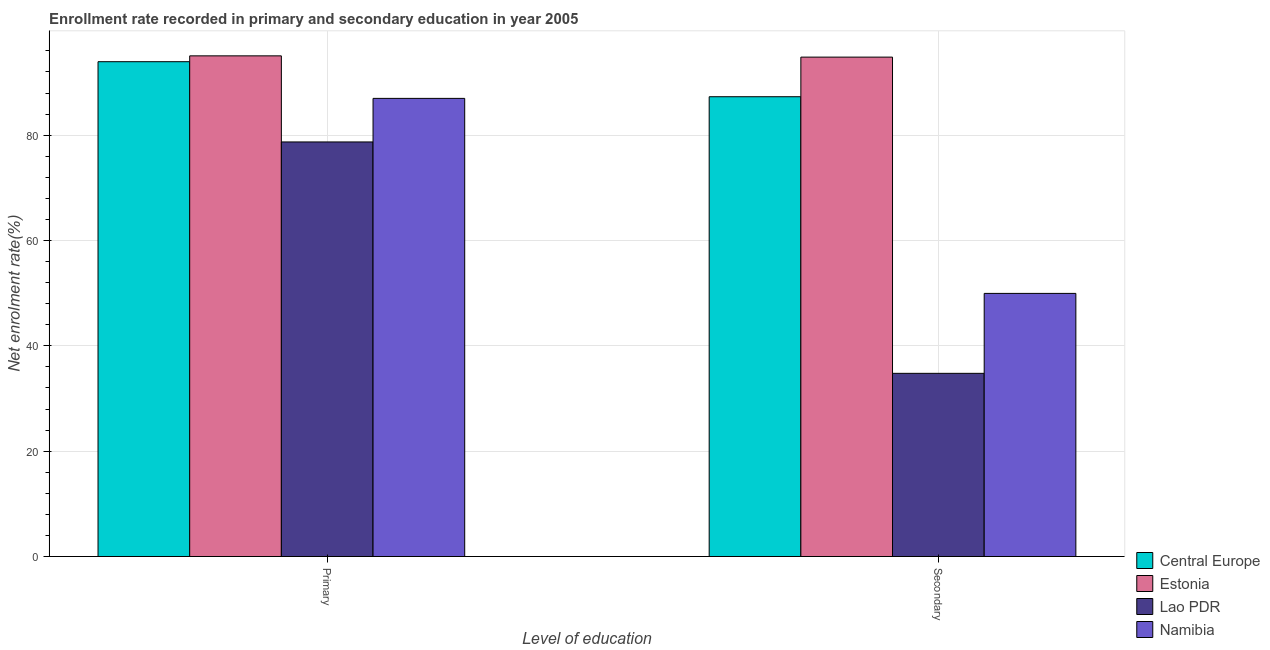How many different coloured bars are there?
Provide a succinct answer. 4. Are the number of bars on each tick of the X-axis equal?
Provide a short and direct response. Yes. How many bars are there on the 1st tick from the left?
Keep it short and to the point. 4. How many bars are there on the 2nd tick from the right?
Keep it short and to the point. 4. What is the label of the 2nd group of bars from the left?
Offer a very short reply. Secondary. What is the enrollment rate in secondary education in Lao PDR?
Offer a terse response. 34.78. Across all countries, what is the maximum enrollment rate in primary education?
Offer a very short reply. 95.05. Across all countries, what is the minimum enrollment rate in secondary education?
Provide a short and direct response. 34.78. In which country was the enrollment rate in secondary education maximum?
Offer a terse response. Estonia. In which country was the enrollment rate in secondary education minimum?
Provide a succinct answer. Lao PDR. What is the total enrollment rate in primary education in the graph?
Offer a terse response. 354.68. What is the difference between the enrollment rate in secondary education in Namibia and that in Central Europe?
Offer a terse response. -37.34. What is the difference between the enrollment rate in secondary education in Lao PDR and the enrollment rate in primary education in Namibia?
Keep it short and to the point. -52.2. What is the average enrollment rate in secondary education per country?
Keep it short and to the point. 66.71. What is the difference between the enrollment rate in secondary education and enrollment rate in primary education in Estonia?
Your answer should be compact. -0.24. In how many countries, is the enrollment rate in secondary education greater than 64 %?
Give a very brief answer. 2. What is the ratio of the enrollment rate in secondary education in Namibia to that in Estonia?
Give a very brief answer. 0.53. What does the 4th bar from the left in Primary represents?
Your answer should be very brief. Namibia. What does the 4th bar from the right in Primary represents?
Your answer should be very brief. Central Europe. How many bars are there?
Make the answer very short. 8. Are all the bars in the graph horizontal?
Offer a terse response. No. How many countries are there in the graph?
Offer a terse response. 4. Are the values on the major ticks of Y-axis written in scientific E-notation?
Ensure brevity in your answer.  No. Does the graph contain any zero values?
Offer a very short reply. No. Does the graph contain grids?
Make the answer very short. Yes. How are the legend labels stacked?
Keep it short and to the point. Vertical. What is the title of the graph?
Your response must be concise. Enrollment rate recorded in primary and secondary education in year 2005. Does "Sao Tome and Principe" appear as one of the legend labels in the graph?
Make the answer very short. No. What is the label or title of the X-axis?
Provide a succinct answer. Level of education. What is the label or title of the Y-axis?
Keep it short and to the point. Net enrolment rate(%). What is the Net enrolment rate(%) in Central Europe in Primary?
Keep it short and to the point. 93.94. What is the Net enrolment rate(%) in Estonia in Primary?
Offer a very short reply. 95.05. What is the Net enrolment rate(%) in Lao PDR in Primary?
Make the answer very short. 78.71. What is the Net enrolment rate(%) of Namibia in Primary?
Give a very brief answer. 86.98. What is the Net enrolment rate(%) in Central Europe in Secondary?
Your answer should be compact. 87.29. What is the Net enrolment rate(%) in Estonia in Secondary?
Your answer should be very brief. 94.81. What is the Net enrolment rate(%) in Lao PDR in Secondary?
Offer a terse response. 34.78. What is the Net enrolment rate(%) of Namibia in Secondary?
Your answer should be very brief. 49.96. Across all Level of education, what is the maximum Net enrolment rate(%) in Central Europe?
Offer a terse response. 93.94. Across all Level of education, what is the maximum Net enrolment rate(%) in Estonia?
Make the answer very short. 95.05. Across all Level of education, what is the maximum Net enrolment rate(%) in Lao PDR?
Ensure brevity in your answer.  78.71. Across all Level of education, what is the maximum Net enrolment rate(%) of Namibia?
Provide a short and direct response. 86.98. Across all Level of education, what is the minimum Net enrolment rate(%) of Central Europe?
Provide a succinct answer. 87.29. Across all Level of education, what is the minimum Net enrolment rate(%) of Estonia?
Ensure brevity in your answer.  94.81. Across all Level of education, what is the minimum Net enrolment rate(%) in Lao PDR?
Provide a succinct answer. 34.78. Across all Level of education, what is the minimum Net enrolment rate(%) in Namibia?
Offer a very short reply. 49.96. What is the total Net enrolment rate(%) of Central Europe in the graph?
Offer a very short reply. 181.24. What is the total Net enrolment rate(%) in Estonia in the graph?
Keep it short and to the point. 189.87. What is the total Net enrolment rate(%) in Lao PDR in the graph?
Your answer should be compact. 113.49. What is the total Net enrolment rate(%) of Namibia in the graph?
Keep it short and to the point. 136.93. What is the difference between the Net enrolment rate(%) of Central Europe in Primary and that in Secondary?
Your answer should be compact. 6.65. What is the difference between the Net enrolment rate(%) of Estonia in Primary and that in Secondary?
Your answer should be compact. 0.24. What is the difference between the Net enrolment rate(%) in Lao PDR in Primary and that in Secondary?
Your response must be concise. 43.93. What is the difference between the Net enrolment rate(%) in Namibia in Primary and that in Secondary?
Your answer should be compact. 37.02. What is the difference between the Net enrolment rate(%) in Central Europe in Primary and the Net enrolment rate(%) in Estonia in Secondary?
Your answer should be very brief. -0.87. What is the difference between the Net enrolment rate(%) in Central Europe in Primary and the Net enrolment rate(%) in Lao PDR in Secondary?
Your response must be concise. 59.16. What is the difference between the Net enrolment rate(%) of Central Europe in Primary and the Net enrolment rate(%) of Namibia in Secondary?
Offer a terse response. 43.99. What is the difference between the Net enrolment rate(%) in Estonia in Primary and the Net enrolment rate(%) in Lao PDR in Secondary?
Keep it short and to the point. 60.27. What is the difference between the Net enrolment rate(%) of Estonia in Primary and the Net enrolment rate(%) of Namibia in Secondary?
Offer a very short reply. 45.1. What is the difference between the Net enrolment rate(%) in Lao PDR in Primary and the Net enrolment rate(%) in Namibia in Secondary?
Your response must be concise. 28.75. What is the average Net enrolment rate(%) of Central Europe per Level of education?
Provide a short and direct response. 90.62. What is the average Net enrolment rate(%) in Estonia per Level of education?
Your response must be concise. 94.93. What is the average Net enrolment rate(%) in Lao PDR per Level of education?
Your answer should be very brief. 56.74. What is the average Net enrolment rate(%) of Namibia per Level of education?
Give a very brief answer. 68.47. What is the difference between the Net enrolment rate(%) of Central Europe and Net enrolment rate(%) of Estonia in Primary?
Ensure brevity in your answer.  -1.11. What is the difference between the Net enrolment rate(%) in Central Europe and Net enrolment rate(%) in Lao PDR in Primary?
Your answer should be very brief. 15.23. What is the difference between the Net enrolment rate(%) of Central Europe and Net enrolment rate(%) of Namibia in Primary?
Your answer should be compact. 6.97. What is the difference between the Net enrolment rate(%) in Estonia and Net enrolment rate(%) in Lao PDR in Primary?
Ensure brevity in your answer.  16.34. What is the difference between the Net enrolment rate(%) in Estonia and Net enrolment rate(%) in Namibia in Primary?
Offer a terse response. 8.07. What is the difference between the Net enrolment rate(%) of Lao PDR and Net enrolment rate(%) of Namibia in Primary?
Your answer should be very brief. -8.27. What is the difference between the Net enrolment rate(%) in Central Europe and Net enrolment rate(%) in Estonia in Secondary?
Your answer should be compact. -7.52. What is the difference between the Net enrolment rate(%) of Central Europe and Net enrolment rate(%) of Lao PDR in Secondary?
Your response must be concise. 52.52. What is the difference between the Net enrolment rate(%) in Central Europe and Net enrolment rate(%) in Namibia in Secondary?
Keep it short and to the point. 37.34. What is the difference between the Net enrolment rate(%) in Estonia and Net enrolment rate(%) in Lao PDR in Secondary?
Keep it short and to the point. 60.03. What is the difference between the Net enrolment rate(%) in Estonia and Net enrolment rate(%) in Namibia in Secondary?
Your answer should be very brief. 44.86. What is the difference between the Net enrolment rate(%) in Lao PDR and Net enrolment rate(%) in Namibia in Secondary?
Your answer should be very brief. -15.18. What is the ratio of the Net enrolment rate(%) in Central Europe in Primary to that in Secondary?
Offer a terse response. 1.08. What is the ratio of the Net enrolment rate(%) of Lao PDR in Primary to that in Secondary?
Your answer should be very brief. 2.26. What is the ratio of the Net enrolment rate(%) in Namibia in Primary to that in Secondary?
Make the answer very short. 1.74. What is the difference between the highest and the second highest Net enrolment rate(%) in Central Europe?
Your response must be concise. 6.65. What is the difference between the highest and the second highest Net enrolment rate(%) of Estonia?
Provide a succinct answer. 0.24. What is the difference between the highest and the second highest Net enrolment rate(%) in Lao PDR?
Your answer should be very brief. 43.93. What is the difference between the highest and the second highest Net enrolment rate(%) of Namibia?
Give a very brief answer. 37.02. What is the difference between the highest and the lowest Net enrolment rate(%) of Central Europe?
Make the answer very short. 6.65. What is the difference between the highest and the lowest Net enrolment rate(%) of Estonia?
Offer a very short reply. 0.24. What is the difference between the highest and the lowest Net enrolment rate(%) of Lao PDR?
Provide a succinct answer. 43.93. What is the difference between the highest and the lowest Net enrolment rate(%) of Namibia?
Give a very brief answer. 37.02. 